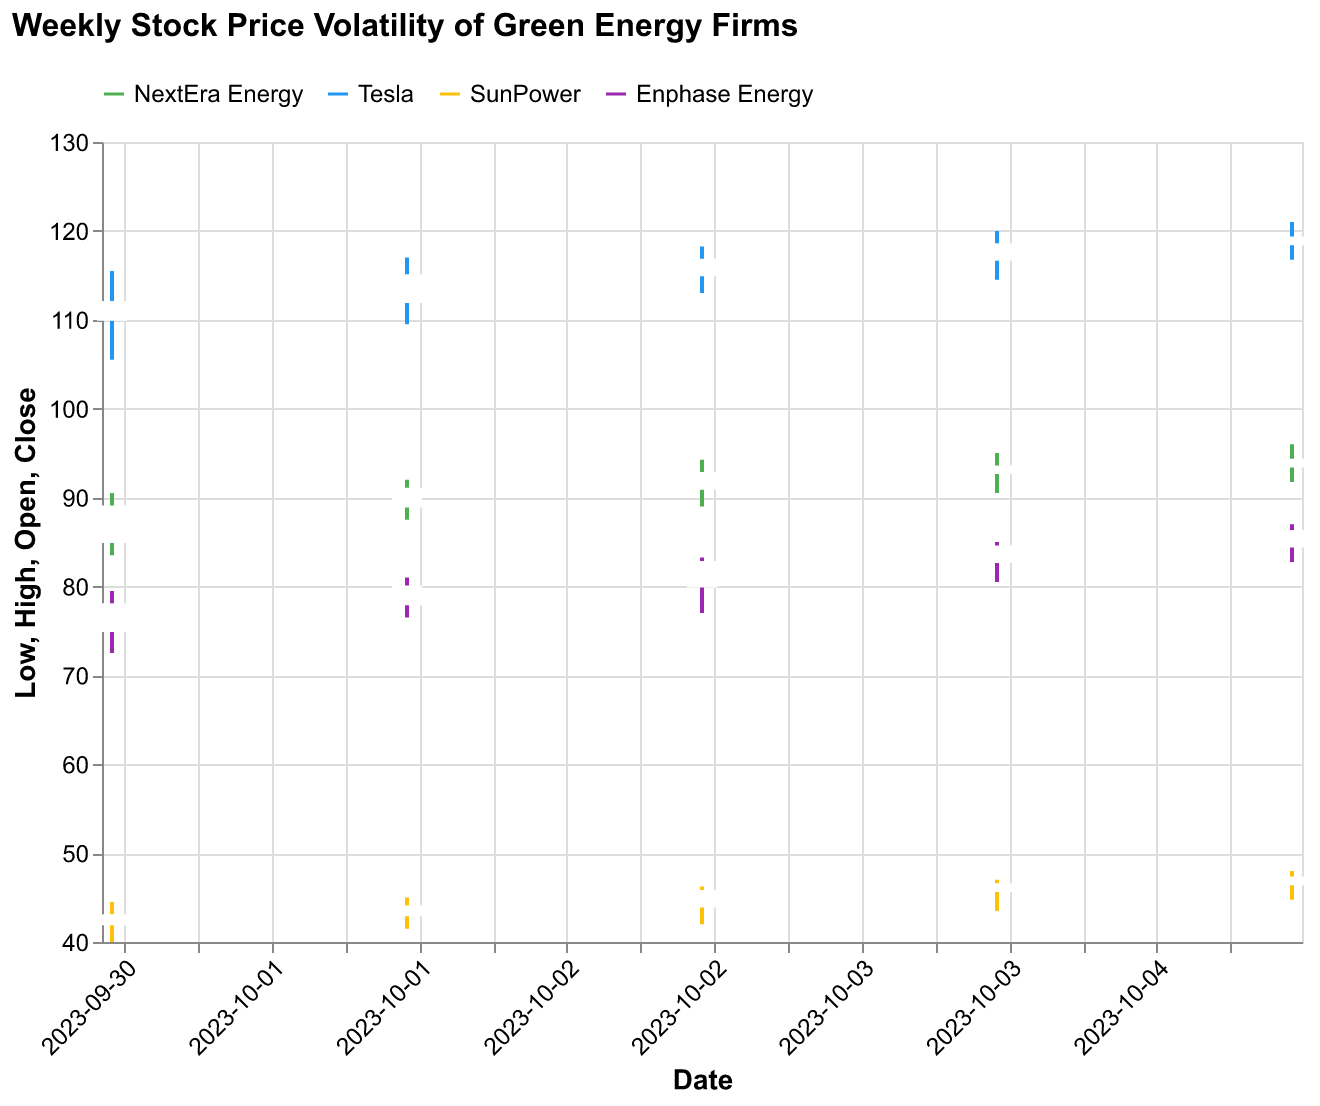What's the title of the figure? The title is normally placed at the top of the figure in a larger font size and often bolded. In this case, the title is "Weekly Stock Price Volatility of Green Energy Firms."
Answer: Weekly Stock Price Volatility of Green Energy Firms Which company has the highest closing stock price on October 5, 2023? By examining the highest closing prices on the candlestick plot for October 5, Tesla's closing stock price is the highest at 119.25.
Answer: Tesla How many companies are represented in the plot? The legend lists all the companies represented in the plot. By looking at the legend, you can see NextEra Energy, Tesla, SunPower, and Enphase Energy, which amounts to four companies.
Answer: Four Which company shows the smallest range between high and low prices on October 3, 2023? To find this, compare the high and low prices (length of the wicks) for each company on October 3. NextEra Energy has a range of 5.25 (94.25 - 89.00), Tesla 5.25 (118.25 - 113.00), SunPower 4.25 (46.25 - 42.00), and Enphase Energy 6.25 (83.25 - 77.00). The smallest range is SunPower with 4.25.
Answer: SunPower What is the average opening stock price for NextEra Energy for the week? NextEra Energy's opening prices are 85.00, 89.00, 91.00, 92.75, and 93.50. To find the average, sum these values and divide by the number of days: (85.00 + 89.00 + 91.00 + 92.75 + 93.50) / 5 = 451.25 / 5 = 90.25.
Answer: 90.25 Which company had the highest trade volume on October 2, 2023? By looking at the volume data points on October 2, Tesla had the highest trade volume listed at 2,250,000.
Answer: Tesla Which company had the lowest closing stock price on October 1, 2023? By examining the closing prices on October 1, SunPower had the lowest closing stock price at 43.00.
Answer: SunPower How did the closing price of Enphase Energy change from October 4 to October 5? On October 4, the closing price of Enphase Energy was 84.50, and on October 5 it was 86.25. The change can be calculated as 86.25 - 84.50 = 1.75.
Answer: It increased by 1.75 For which company was the difference between opening and closing prices the largest on any day of the dataset? The difference between opening and closing prices can be calculated for each day for all companies. Tesla on October 2 had the largest difference: 5.00 (117.00 - 112.00).
Answer: Tesla 